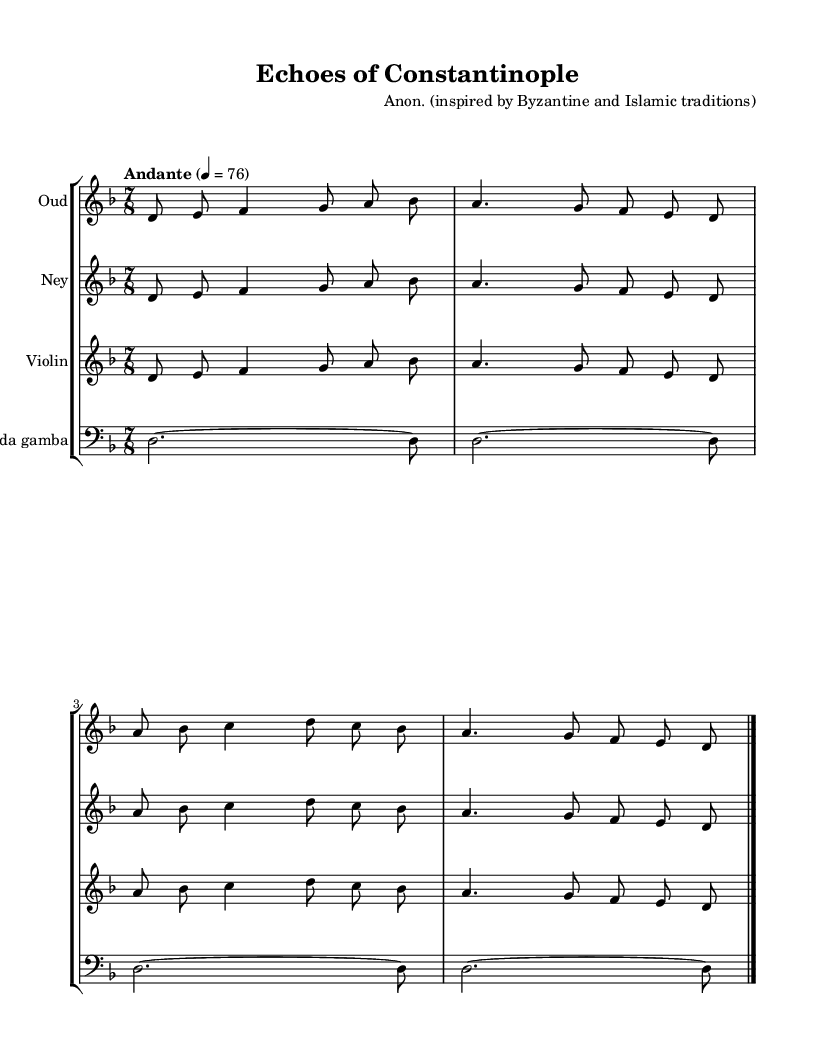What is the key signature of this music? The key signature displayed consists of one flat, indicating it is in D minor.
Answer: D minor What is the time signature of this piece? The time signature shown is 7/8, which means there are seven eighth notes in each measure.
Answer: 7/8 What is the tempo marking for this music? The tempo marking indicates "Andante," which indicates a moderately slow tempo.
Answer: Andante How many instruments are scored in this chamber music? There are four instruments indicated in the score: Oud, Ney, Violin, and Viola da gamba.
Answer: Four What is the total number of measures in the music provided? By examining the measures in the provided score, there are four measures for each instrument in the music. Therefore, there are a total of four measures present.
Answer: Four Explain how the oud and ney parts compare in the first four measures. Both the oud and ney play the same melodic line in the first four measures, exhibiting parallel harmony and rhythm, which shows their interconnectedness in traditional music.
Answer: Similar 